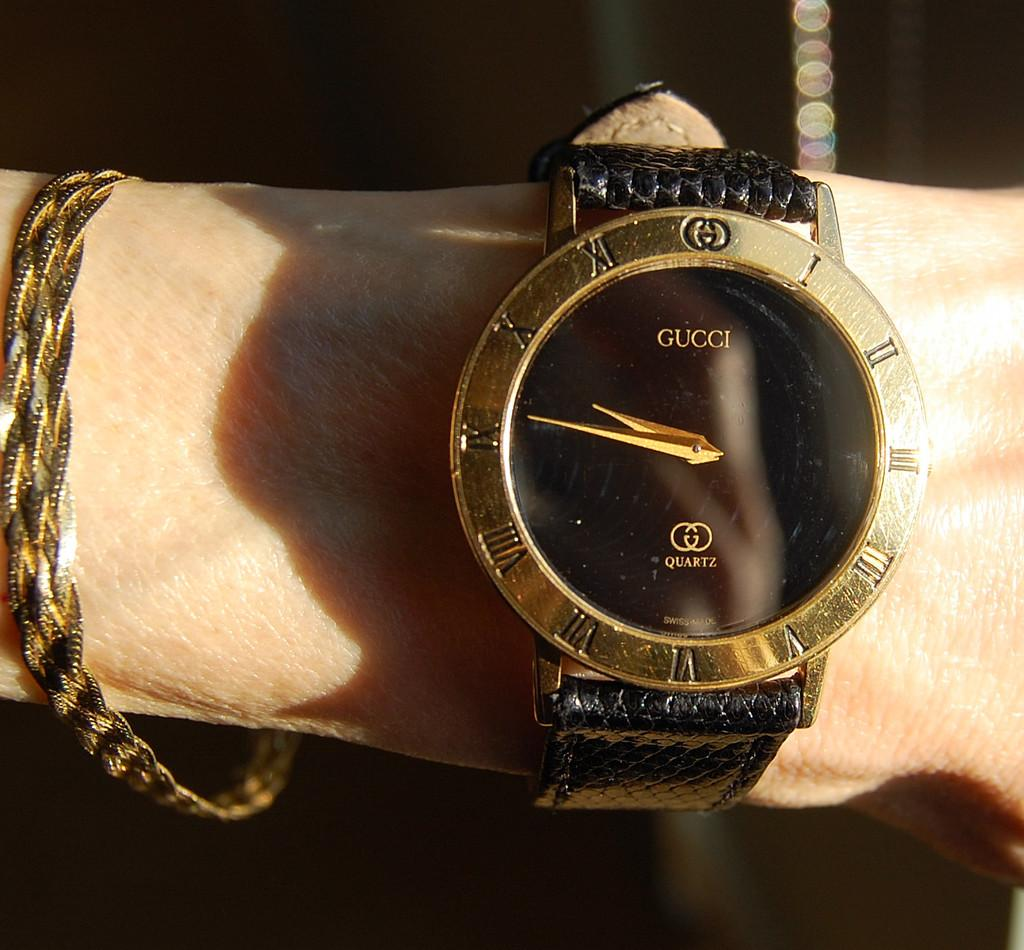Provide a one-sentence caption for the provided image. A person is wearing a gold and black Gucci wristwatch. 